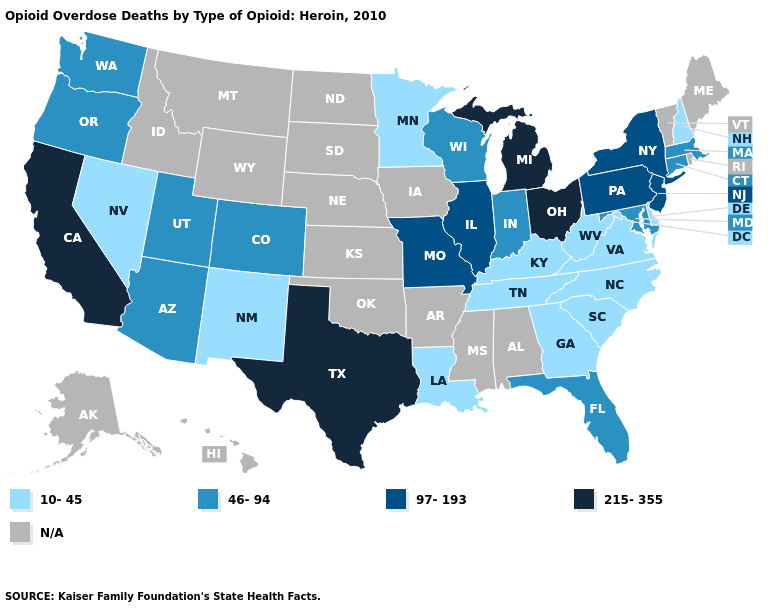How many symbols are there in the legend?
Be succinct. 5. Name the states that have a value in the range 46-94?
Concise answer only. Arizona, Colorado, Connecticut, Florida, Indiana, Maryland, Massachusetts, Oregon, Utah, Washington, Wisconsin. What is the value of Wyoming?
Be succinct. N/A. Does Louisiana have the lowest value in the USA?
Quick response, please. Yes. Name the states that have a value in the range N/A?
Write a very short answer. Alabama, Alaska, Arkansas, Hawaii, Idaho, Iowa, Kansas, Maine, Mississippi, Montana, Nebraska, North Dakota, Oklahoma, Rhode Island, South Dakota, Vermont, Wyoming. Which states hav the highest value in the South?
Keep it brief. Texas. Does Virginia have the lowest value in the USA?
Answer briefly. Yes. Which states hav the highest value in the Northeast?
Keep it brief. New Jersey, New York, Pennsylvania. Name the states that have a value in the range N/A?
Give a very brief answer. Alabama, Alaska, Arkansas, Hawaii, Idaho, Iowa, Kansas, Maine, Mississippi, Montana, Nebraska, North Dakota, Oklahoma, Rhode Island, South Dakota, Vermont, Wyoming. Which states have the highest value in the USA?
Be succinct. California, Michigan, Ohio, Texas. Does the first symbol in the legend represent the smallest category?
Be succinct. Yes. 